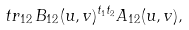<formula> <loc_0><loc_0><loc_500><loc_500>\ t r _ { 1 2 } \, B _ { 1 2 } ( u , v ) ^ { t _ { 1 } t _ { 2 } } A _ { 1 2 } ( u , v ) ,</formula> 